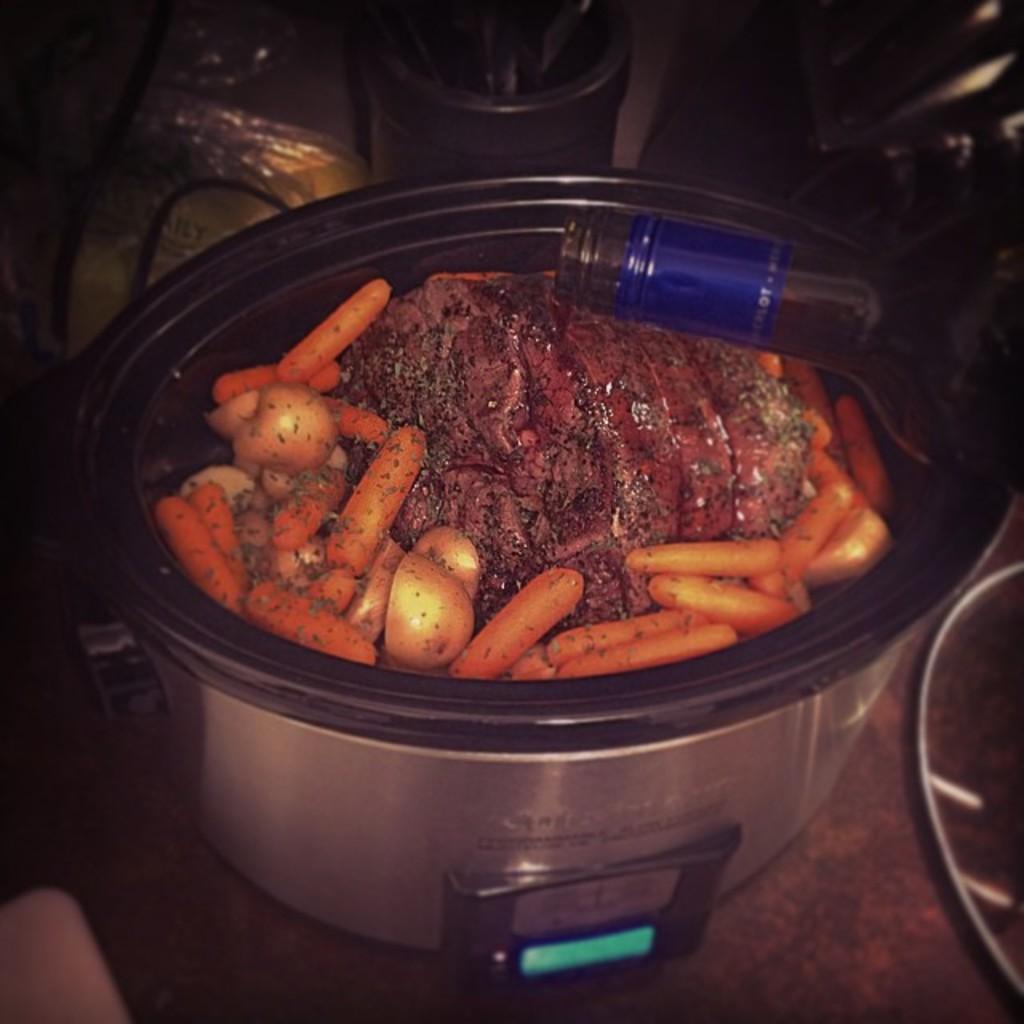How would you summarize this image in a sentence or two? In this image, we can see some food item in a container. We can see a bottle. We can also see some object on the right. We can also see an object on the bottom left corner. We can also see some objects at the top. 